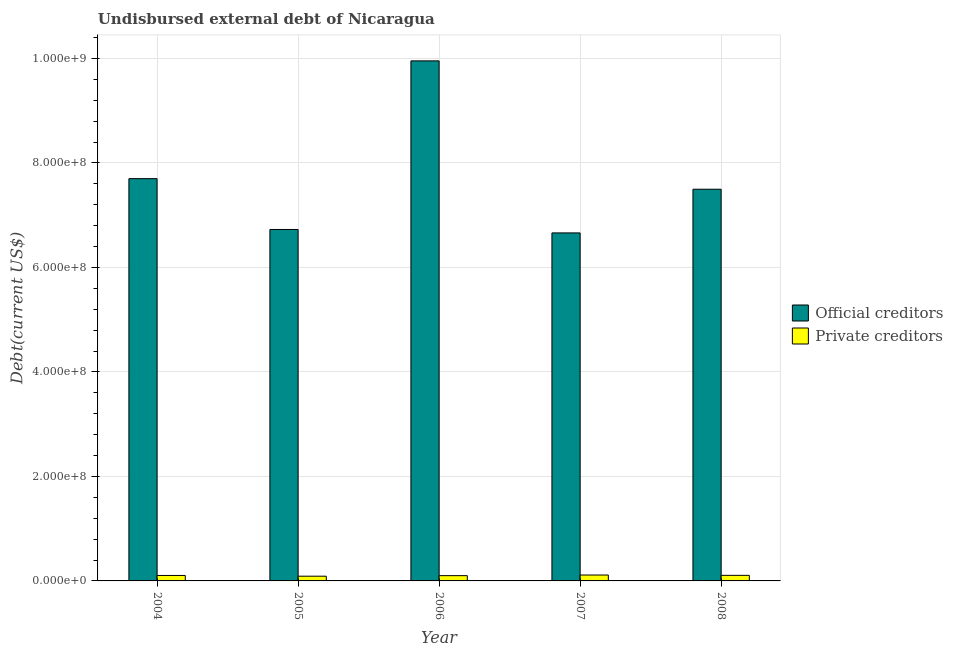How many groups of bars are there?
Provide a short and direct response. 5. How many bars are there on the 2nd tick from the right?
Make the answer very short. 2. What is the label of the 3rd group of bars from the left?
Keep it short and to the point. 2006. In how many cases, is the number of bars for a given year not equal to the number of legend labels?
Ensure brevity in your answer.  0. What is the undisbursed external debt of official creditors in 2005?
Your answer should be very brief. 6.73e+08. Across all years, what is the maximum undisbursed external debt of private creditors?
Provide a short and direct response. 1.13e+07. Across all years, what is the minimum undisbursed external debt of private creditors?
Make the answer very short. 9.05e+06. In which year was the undisbursed external debt of official creditors maximum?
Provide a short and direct response. 2006. In which year was the undisbursed external debt of official creditors minimum?
Your answer should be compact. 2007. What is the total undisbursed external debt of official creditors in the graph?
Keep it short and to the point. 3.85e+09. What is the difference between the undisbursed external debt of official creditors in 2005 and that in 2006?
Offer a very short reply. -3.23e+08. What is the difference between the undisbursed external debt of private creditors in 2008 and the undisbursed external debt of official creditors in 2006?
Your answer should be compact. 5.73e+05. What is the average undisbursed external debt of official creditors per year?
Your response must be concise. 7.71e+08. In how many years, is the undisbursed external debt of official creditors greater than 40000000 US$?
Give a very brief answer. 5. What is the ratio of the undisbursed external debt of private creditors in 2005 to that in 2007?
Give a very brief answer. 0.8. Is the undisbursed external debt of official creditors in 2005 less than that in 2008?
Offer a terse response. Yes. What is the difference between the highest and the second highest undisbursed external debt of official creditors?
Your answer should be very brief. 2.25e+08. What is the difference between the highest and the lowest undisbursed external debt of official creditors?
Offer a terse response. 3.29e+08. In how many years, is the undisbursed external debt of official creditors greater than the average undisbursed external debt of official creditors taken over all years?
Provide a short and direct response. 1. What does the 1st bar from the left in 2006 represents?
Give a very brief answer. Official creditors. What does the 2nd bar from the right in 2008 represents?
Provide a succinct answer. Official creditors. Does the graph contain any zero values?
Ensure brevity in your answer.  No. Does the graph contain grids?
Give a very brief answer. Yes. What is the title of the graph?
Your answer should be compact. Undisbursed external debt of Nicaragua. Does "Food" appear as one of the legend labels in the graph?
Give a very brief answer. No. What is the label or title of the X-axis?
Make the answer very short. Year. What is the label or title of the Y-axis?
Offer a very short reply. Debt(current US$). What is the Debt(current US$) of Official creditors in 2004?
Your answer should be very brief. 7.70e+08. What is the Debt(current US$) in Private creditors in 2004?
Your answer should be very brief. 1.04e+07. What is the Debt(current US$) in Official creditors in 2005?
Your answer should be compact. 6.73e+08. What is the Debt(current US$) of Private creditors in 2005?
Your answer should be compact. 9.05e+06. What is the Debt(current US$) in Official creditors in 2006?
Ensure brevity in your answer.  9.95e+08. What is the Debt(current US$) in Private creditors in 2006?
Offer a terse response. 1.01e+07. What is the Debt(current US$) of Official creditors in 2007?
Make the answer very short. 6.66e+08. What is the Debt(current US$) of Private creditors in 2007?
Ensure brevity in your answer.  1.13e+07. What is the Debt(current US$) of Official creditors in 2008?
Provide a short and direct response. 7.50e+08. What is the Debt(current US$) in Private creditors in 2008?
Your answer should be very brief. 1.07e+07. Across all years, what is the maximum Debt(current US$) of Official creditors?
Give a very brief answer. 9.95e+08. Across all years, what is the maximum Debt(current US$) in Private creditors?
Offer a terse response. 1.13e+07. Across all years, what is the minimum Debt(current US$) in Official creditors?
Your answer should be very brief. 6.66e+08. Across all years, what is the minimum Debt(current US$) in Private creditors?
Your response must be concise. 9.05e+06. What is the total Debt(current US$) in Official creditors in the graph?
Offer a terse response. 3.85e+09. What is the total Debt(current US$) of Private creditors in the graph?
Make the answer very short. 5.16e+07. What is the difference between the Debt(current US$) of Official creditors in 2004 and that in 2005?
Keep it short and to the point. 9.73e+07. What is the difference between the Debt(current US$) in Private creditors in 2004 and that in 2005?
Keep it short and to the point. 1.40e+06. What is the difference between the Debt(current US$) of Official creditors in 2004 and that in 2006?
Give a very brief answer. -2.25e+08. What is the difference between the Debt(current US$) of Private creditors in 2004 and that in 2006?
Provide a short and direct response. 3.46e+05. What is the difference between the Debt(current US$) in Official creditors in 2004 and that in 2007?
Offer a very short reply. 1.04e+08. What is the difference between the Debt(current US$) in Private creditors in 2004 and that in 2007?
Your response must be concise. -8.44e+05. What is the difference between the Debt(current US$) of Official creditors in 2004 and that in 2008?
Offer a terse response. 2.03e+07. What is the difference between the Debt(current US$) of Private creditors in 2004 and that in 2008?
Provide a succinct answer. -2.27e+05. What is the difference between the Debt(current US$) in Official creditors in 2005 and that in 2006?
Your response must be concise. -3.23e+08. What is the difference between the Debt(current US$) of Private creditors in 2005 and that in 2006?
Your response must be concise. -1.05e+06. What is the difference between the Debt(current US$) of Official creditors in 2005 and that in 2007?
Provide a succinct answer. 6.59e+06. What is the difference between the Debt(current US$) in Private creditors in 2005 and that in 2007?
Provide a short and direct response. -2.24e+06. What is the difference between the Debt(current US$) of Official creditors in 2005 and that in 2008?
Keep it short and to the point. -7.70e+07. What is the difference between the Debt(current US$) of Private creditors in 2005 and that in 2008?
Your response must be concise. -1.63e+06. What is the difference between the Debt(current US$) in Official creditors in 2006 and that in 2007?
Ensure brevity in your answer.  3.29e+08. What is the difference between the Debt(current US$) in Private creditors in 2006 and that in 2007?
Offer a very short reply. -1.19e+06. What is the difference between the Debt(current US$) in Official creditors in 2006 and that in 2008?
Your answer should be very brief. 2.46e+08. What is the difference between the Debt(current US$) of Private creditors in 2006 and that in 2008?
Provide a succinct answer. -5.73e+05. What is the difference between the Debt(current US$) of Official creditors in 2007 and that in 2008?
Provide a succinct answer. -8.36e+07. What is the difference between the Debt(current US$) in Private creditors in 2007 and that in 2008?
Offer a terse response. 6.17e+05. What is the difference between the Debt(current US$) in Official creditors in 2004 and the Debt(current US$) in Private creditors in 2005?
Provide a short and direct response. 7.61e+08. What is the difference between the Debt(current US$) in Official creditors in 2004 and the Debt(current US$) in Private creditors in 2006?
Make the answer very short. 7.60e+08. What is the difference between the Debt(current US$) in Official creditors in 2004 and the Debt(current US$) in Private creditors in 2007?
Keep it short and to the point. 7.59e+08. What is the difference between the Debt(current US$) in Official creditors in 2004 and the Debt(current US$) in Private creditors in 2008?
Make the answer very short. 7.59e+08. What is the difference between the Debt(current US$) in Official creditors in 2005 and the Debt(current US$) in Private creditors in 2006?
Offer a terse response. 6.63e+08. What is the difference between the Debt(current US$) in Official creditors in 2005 and the Debt(current US$) in Private creditors in 2007?
Give a very brief answer. 6.61e+08. What is the difference between the Debt(current US$) in Official creditors in 2005 and the Debt(current US$) in Private creditors in 2008?
Offer a very short reply. 6.62e+08. What is the difference between the Debt(current US$) of Official creditors in 2006 and the Debt(current US$) of Private creditors in 2007?
Your answer should be compact. 9.84e+08. What is the difference between the Debt(current US$) in Official creditors in 2006 and the Debt(current US$) in Private creditors in 2008?
Offer a terse response. 9.85e+08. What is the difference between the Debt(current US$) in Official creditors in 2007 and the Debt(current US$) in Private creditors in 2008?
Your answer should be compact. 6.55e+08. What is the average Debt(current US$) in Official creditors per year?
Offer a terse response. 7.71e+08. What is the average Debt(current US$) of Private creditors per year?
Your answer should be compact. 1.03e+07. In the year 2004, what is the difference between the Debt(current US$) of Official creditors and Debt(current US$) of Private creditors?
Provide a short and direct response. 7.60e+08. In the year 2005, what is the difference between the Debt(current US$) of Official creditors and Debt(current US$) of Private creditors?
Give a very brief answer. 6.64e+08. In the year 2006, what is the difference between the Debt(current US$) of Official creditors and Debt(current US$) of Private creditors?
Offer a terse response. 9.85e+08. In the year 2007, what is the difference between the Debt(current US$) of Official creditors and Debt(current US$) of Private creditors?
Keep it short and to the point. 6.55e+08. In the year 2008, what is the difference between the Debt(current US$) in Official creditors and Debt(current US$) in Private creditors?
Your answer should be very brief. 7.39e+08. What is the ratio of the Debt(current US$) in Official creditors in 2004 to that in 2005?
Your response must be concise. 1.14. What is the ratio of the Debt(current US$) in Private creditors in 2004 to that in 2005?
Provide a succinct answer. 1.15. What is the ratio of the Debt(current US$) of Official creditors in 2004 to that in 2006?
Offer a terse response. 0.77. What is the ratio of the Debt(current US$) in Private creditors in 2004 to that in 2006?
Give a very brief answer. 1.03. What is the ratio of the Debt(current US$) of Official creditors in 2004 to that in 2007?
Offer a terse response. 1.16. What is the ratio of the Debt(current US$) of Private creditors in 2004 to that in 2007?
Keep it short and to the point. 0.93. What is the ratio of the Debt(current US$) of Official creditors in 2004 to that in 2008?
Give a very brief answer. 1.03. What is the ratio of the Debt(current US$) of Private creditors in 2004 to that in 2008?
Your answer should be compact. 0.98. What is the ratio of the Debt(current US$) in Official creditors in 2005 to that in 2006?
Keep it short and to the point. 0.68. What is the ratio of the Debt(current US$) of Private creditors in 2005 to that in 2006?
Keep it short and to the point. 0.9. What is the ratio of the Debt(current US$) of Official creditors in 2005 to that in 2007?
Your response must be concise. 1.01. What is the ratio of the Debt(current US$) in Private creditors in 2005 to that in 2007?
Make the answer very short. 0.8. What is the ratio of the Debt(current US$) in Official creditors in 2005 to that in 2008?
Provide a short and direct response. 0.9. What is the ratio of the Debt(current US$) of Private creditors in 2005 to that in 2008?
Offer a terse response. 0.85. What is the ratio of the Debt(current US$) of Official creditors in 2006 to that in 2007?
Your answer should be very brief. 1.49. What is the ratio of the Debt(current US$) in Private creditors in 2006 to that in 2007?
Offer a very short reply. 0.89. What is the ratio of the Debt(current US$) of Official creditors in 2006 to that in 2008?
Make the answer very short. 1.33. What is the ratio of the Debt(current US$) in Private creditors in 2006 to that in 2008?
Give a very brief answer. 0.95. What is the ratio of the Debt(current US$) in Official creditors in 2007 to that in 2008?
Ensure brevity in your answer.  0.89. What is the ratio of the Debt(current US$) in Private creditors in 2007 to that in 2008?
Give a very brief answer. 1.06. What is the difference between the highest and the second highest Debt(current US$) of Official creditors?
Ensure brevity in your answer.  2.25e+08. What is the difference between the highest and the second highest Debt(current US$) in Private creditors?
Your answer should be very brief. 6.17e+05. What is the difference between the highest and the lowest Debt(current US$) of Official creditors?
Provide a short and direct response. 3.29e+08. What is the difference between the highest and the lowest Debt(current US$) of Private creditors?
Provide a short and direct response. 2.24e+06. 